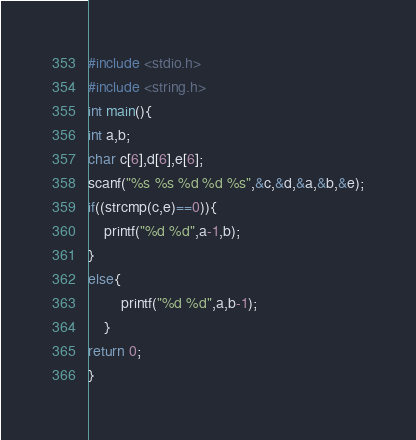<code> <loc_0><loc_0><loc_500><loc_500><_C_>#include <stdio.h>
#include <string.h>
int main(){
int a,b;
char c[6],d[6],e[6];
scanf("%s %s %d %d %s",&c,&d,&a,&b,&e);
if((strcmp(c,e)==0)){
	printf("%d %d",a-1,b);
}
else{
		printf("%d %d",a,b-1);
	}
return 0;
}</code> 